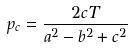<formula> <loc_0><loc_0><loc_500><loc_500>p _ { c } = \frac { 2 c T } { a ^ { 2 } - b ^ { 2 } + c ^ { 2 } }</formula> 